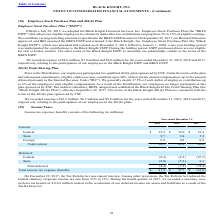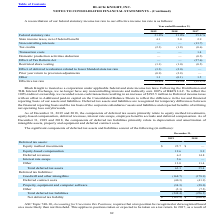According to Black Knight Financial Services's financial document, What did the components of deferred tax assets primarily related to? equity method investments, equity-based compensation, deferred revenues, interest rate swaps, employee benefits accruals and deferred compensation. The document states: "onents of deferred tax assets primarily relate to equity method investments, equity-based compensation, deferred revenues, interest rate swaps, employ..." Also, What was the amount of Equity method investments in 2019? According to the financial document, 25.7 (in millions). The relevant text states: "Equity method investments $ 25.7 $ —..." Also, Which years does the table provide information for  components of deferred tax assets and liabilities? The document shows two values: 2019 and 2018. From the document: "2019 2018 2017 2019 2018 2017..." Also, can you calculate: What was the change in equity-based compensation between 2018 and 2019? Based on the calculation: 12.6-9.2, the result is 3.4 (in millions). This is based on the information: "Equity-based compensation 12.6 9.2 Equity-based compensation 12.6 9.2..." The key data points involved are: 12.6, 9.2. Also, How many years did deferred revenues exceed $10 million? Based on the analysis, there are 1 instances. The counting process: 2018. Also, can you calculate: What was the percentage change in Total deferred tax liabilities between 2018 and 2019? To answer this question, I need to perform calculations using the financial data. The calculation is: (-248.4-(-256.3))/-256.3, which equals -3.08 (percentage). This is based on the information: "Total deferred tax liabilities (248.4) (256.3) Total deferred tax liabilities (248.4) (256.3)..." The key data points involved are: 248.4, 256.3. 